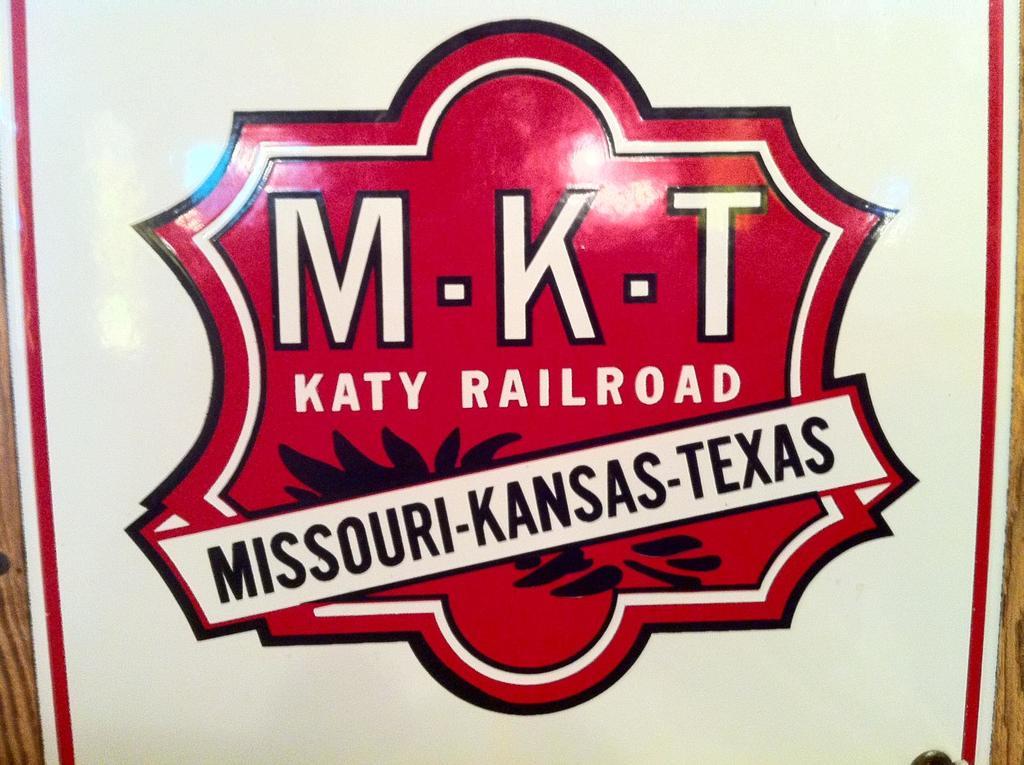How many teams are playing?
Make the answer very short. 3. What are the initals on the sign?
Your answer should be compact. Mkt. 